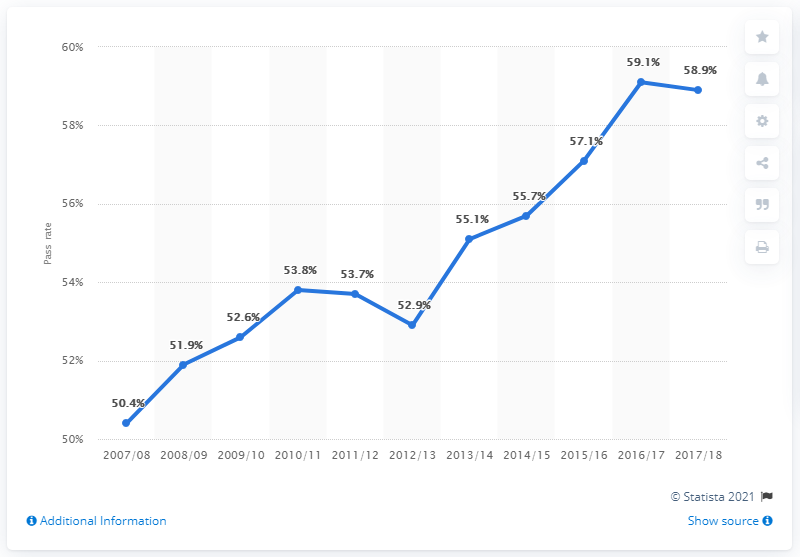Specify some key components in this picture. The pass rate for passenger carrying vehicles between 2007/2008 and 2017/2018 was 58.9%. In 2017/2018, 58.9% of passenger vehicle safety tests conducted in Great Britain were successful. 